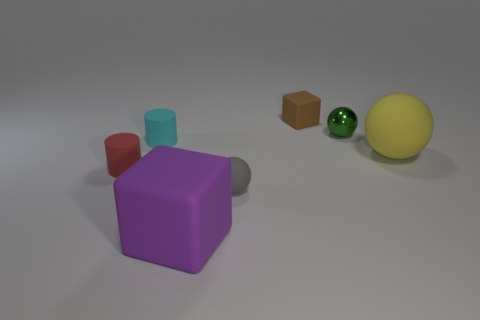There is a matte block that is behind the cylinder that is behind the large rubber ball; what is its size?
Your answer should be very brief. Small. There is a matte ball that is on the left side of the small shiny sphere; what is its size?
Provide a short and direct response. Small. What number of other things are there of the same color as the small metal sphere?
Offer a very short reply. 0. What is the material of the tiny sphere in front of the large rubber thing that is behind the red cylinder?
Make the answer very short. Rubber. There is a big object that is right of the big purple rubber block; does it have the same color as the large block?
Your answer should be compact. No. Is there anything else that has the same material as the brown cube?
Ensure brevity in your answer.  Yes. What number of tiny brown things have the same shape as the green shiny object?
Ensure brevity in your answer.  0. There is a red cylinder that is the same material as the cyan cylinder; what is its size?
Provide a succinct answer. Small. Is there a large sphere that is left of the matte block behind the matte cube left of the tiny brown cube?
Provide a short and direct response. No. Do the matte cube in front of the green thing and the tiny red rubber cylinder have the same size?
Make the answer very short. No. 